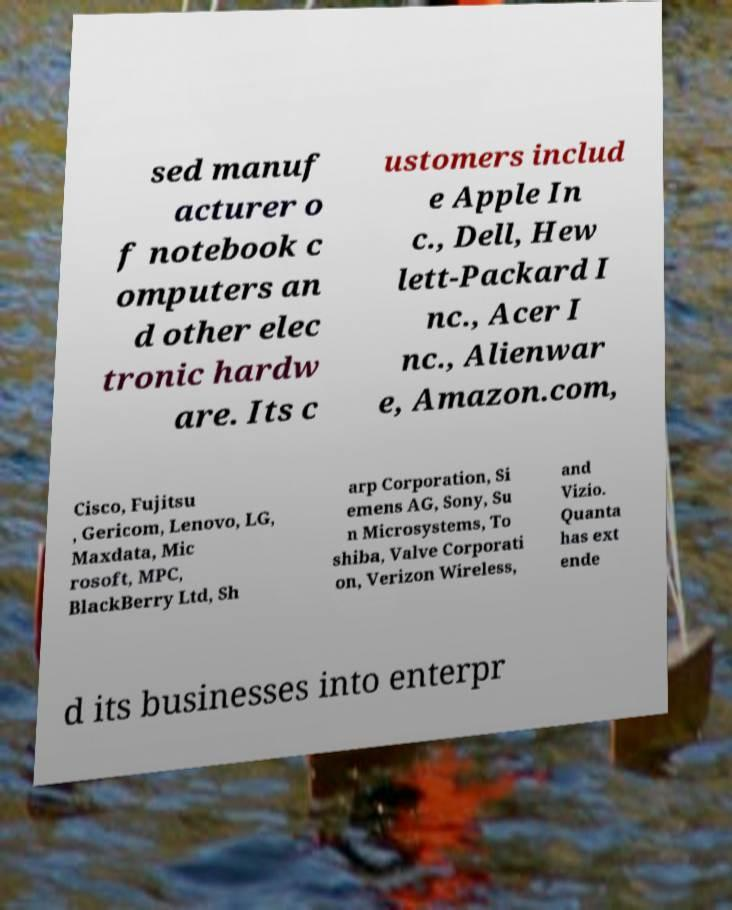What messages or text are displayed in this image? I need them in a readable, typed format. sed manuf acturer o f notebook c omputers an d other elec tronic hardw are. Its c ustomers includ e Apple In c., Dell, Hew lett-Packard I nc., Acer I nc., Alienwar e, Amazon.com, Cisco, Fujitsu , Gericom, Lenovo, LG, Maxdata, Mic rosoft, MPC, BlackBerry Ltd, Sh arp Corporation, Si emens AG, Sony, Su n Microsystems, To shiba, Valve Corporati on, Verizon Wireless, and Vizio. Quanta has ext ende d its businesses into enterpr 